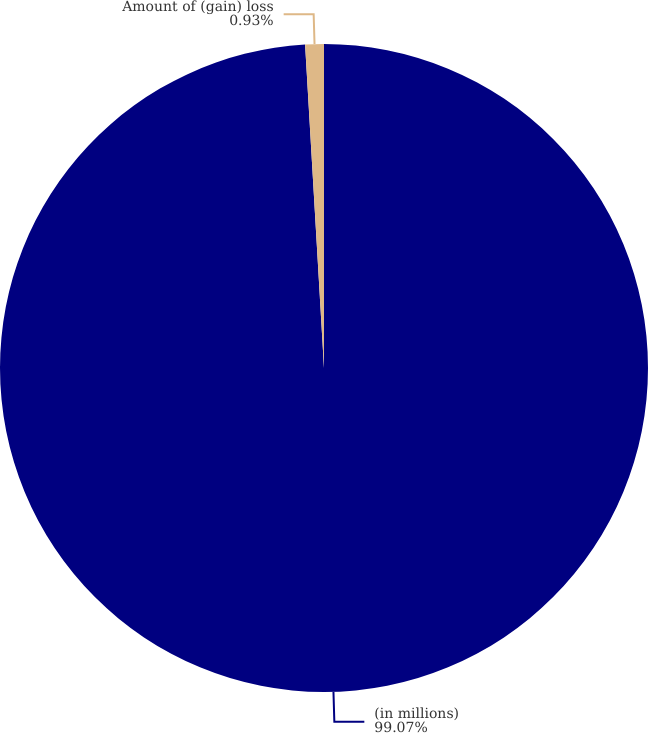Convert chart to OTSL. <chart><loc_0><loc_0><loc_500><loc_500><pie_chart><fcel>(in millions)<fcel>Amount of (gain) loss<nl><fcel>99.07%<fcel>0.93%<nl></chart> 